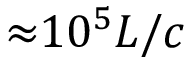Convert formula to latex. <formula><loc_0><loc_0><loc_500><loc_500>{ \approx } 1 0 ^ { 5 } L / c</formula> 